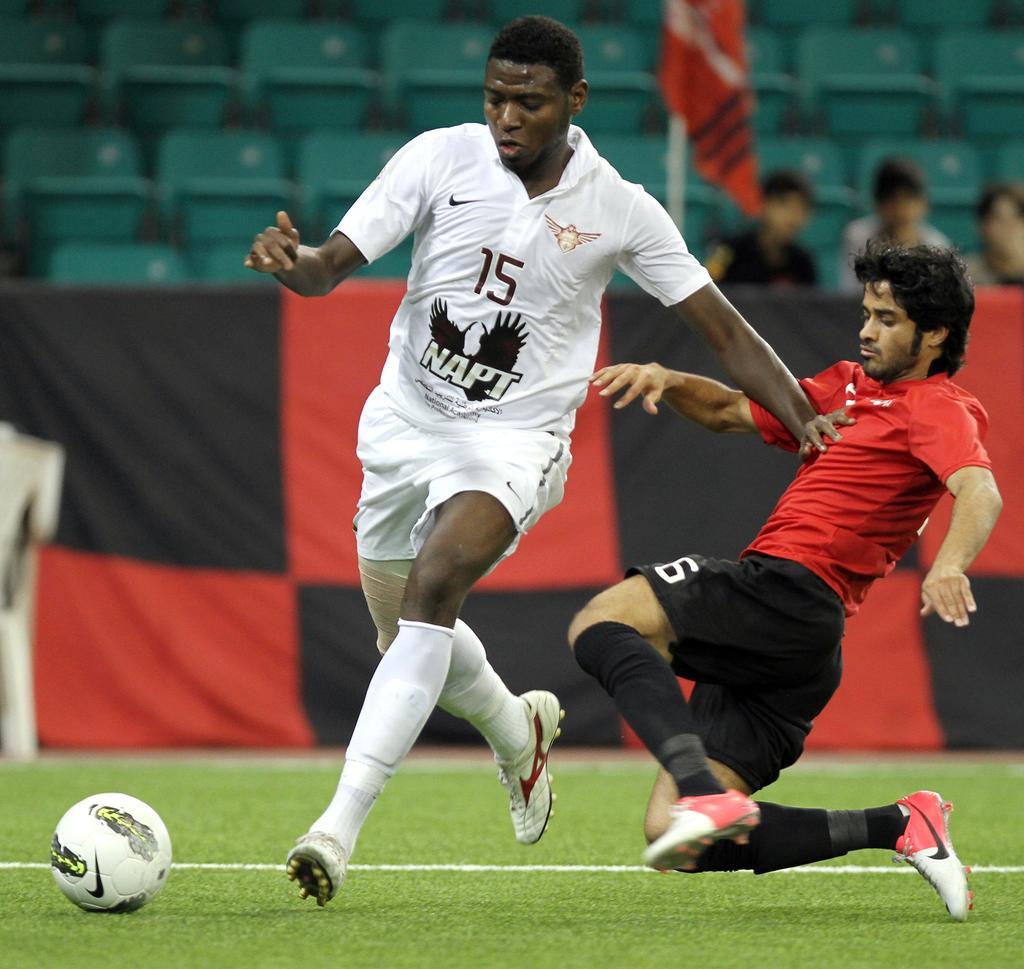Can you describe this image briefly? In this picture there is a man who is wearing white dress. Beside him we can see another man who is wearing red t-shirt, short and shoe. Both of them are running to hit the football. At the bottom we can see the grass. In the background we can see the stadium, flag and cloth. At the top right corner there are three persons sitting on the chair. 